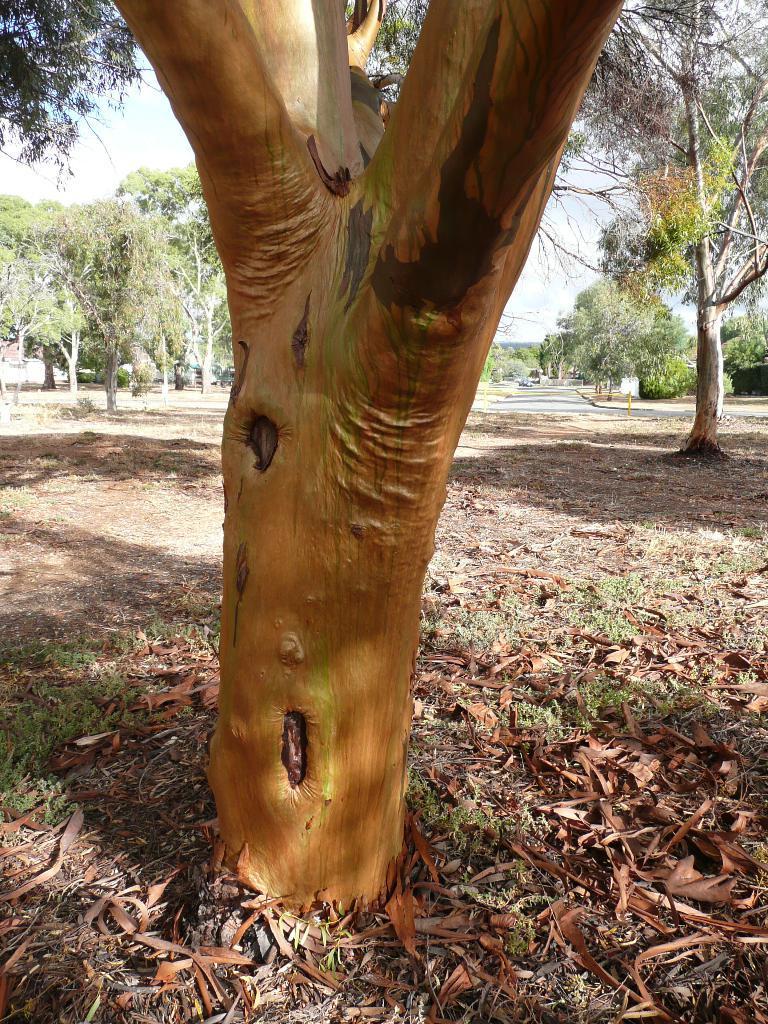How would you summarize this image in a sentence or two? This image looks like it is clicked in the forest. In the front, there is a tree. At the bottom, there are dried leaves and grass. In the background, there are many trees. At the top, there is a sky. 